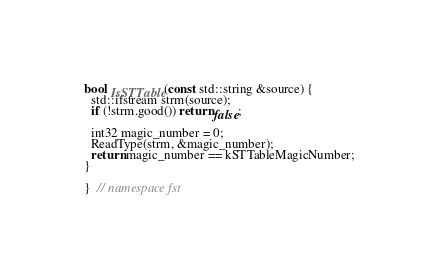<code> <loc_0><loc_0><loc_500><loc_500><_C++_>
bool IsSTTable(const std::string &source) {
  std::ifstream strm(source);
  if (!strm.good()) return false;

  int32 magic_number = 0;
  ReadType(strm, &magic_number);
  return magic_number == kSTTableMagicNumber;
}

}  // namespace fst
</code> 